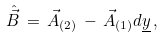<formula> <loc_0><loc_0><loc_500><loc_500>\hat { \vec { B } } \, = \, \vec { A } _ { ( 2 ) } \, - \, \vec { A } _ { ( 1 ) } d \underline { y } \, ,</formula> 